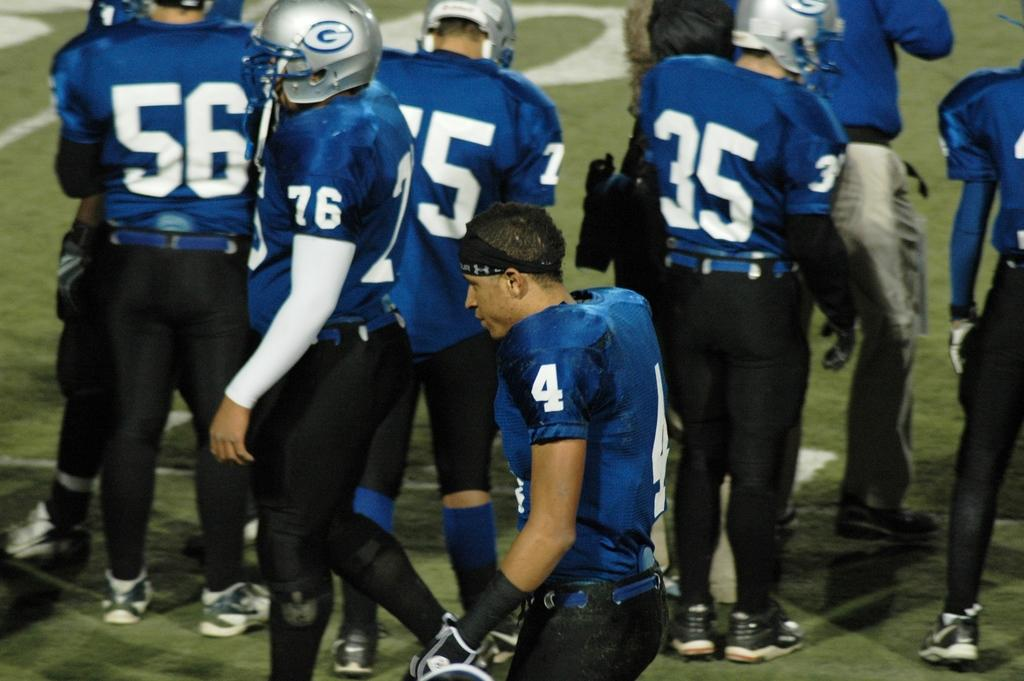What is the main subject of the picture? The main subject of the picture is a group of sportsmen. What is the setting of the picture? The sportsmen are standing on green grass. What protective gear are some of the sportsmen wearing? Some of the sportsmen are wearing helmets on their heads. What type of party is being held in the image? There is no party depicted in the image; it features a group of sportsmen standing on green grass. What is the sportsmen's belief about the importance of wearing helmets? The image does not provide information about the sportsmen's beliefs or opinions regarding helmets. 